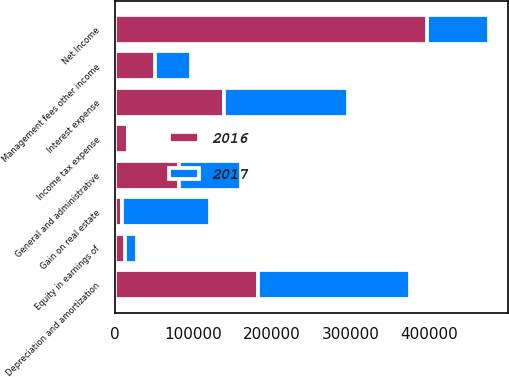<chart> <loc_0><loc_0><loc_500><loc_500><stacked_bar_chart><ecel><fcel>Net Income<fcel>Gain on real estate<fcel>Equity in earnings of<fcel>Interest expense<fcel>Depreciation and amortization<fcel>Income tax expense<fcel>General and administrative<fcel>Management fees other income<nl><fcel>2017<fcel>78961<fcel>112789<fcel>15331<fcel>158614<fcel>193296<fcel>3625<fcel>78961<fcel>46115<nl><fcel>2016<fcel>397089<fcel>8465<fcel>12895<fcel>138459<fcel>182560<fcel>15847<fcel>81806<fcel>50840<nl></chart> 